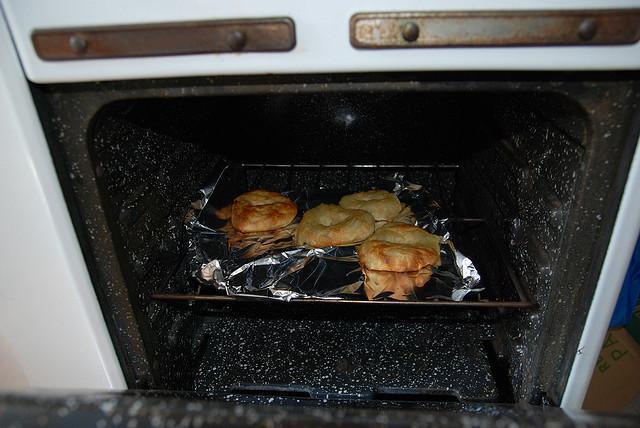What is safest to touch without being burned?
Pick the right solution, then justify: 'Answer: answer
Rationale: rationale.'
Options: Foil, inside stove, food, pan. Answer: foil.
Rationale: The foil is safe. 